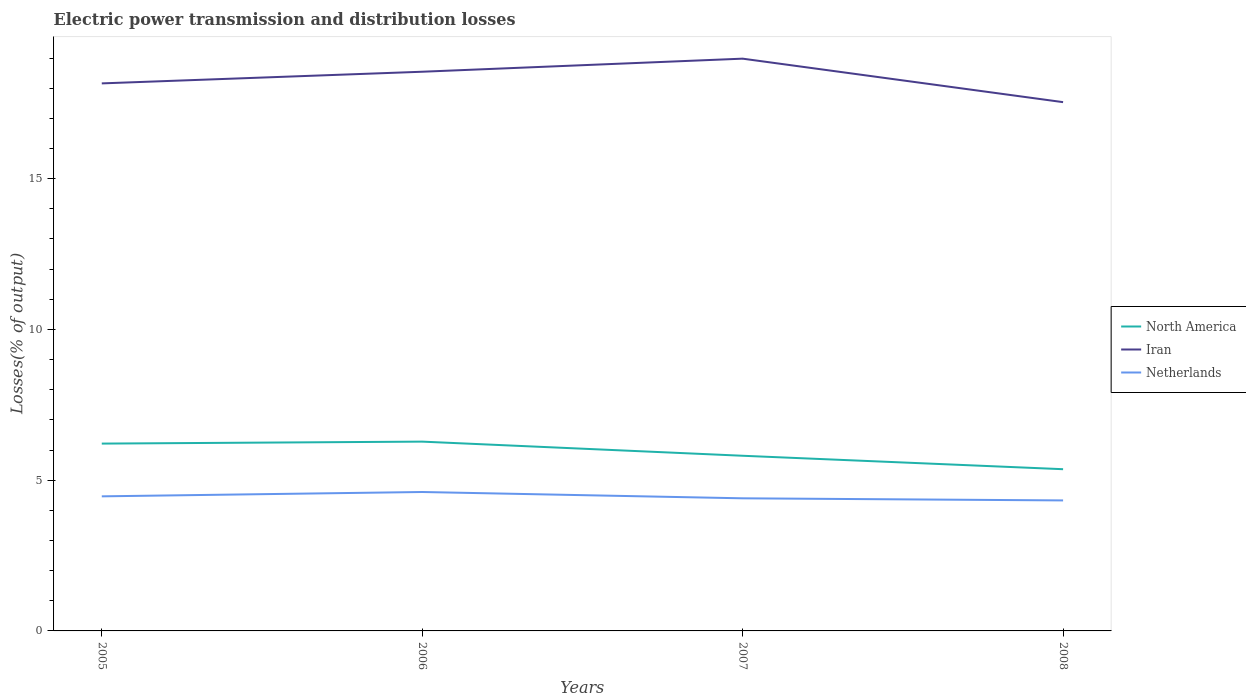Across all years, what is the maximum electric power transmission and distribution losses in North America?
Your answer should be compact. 5.36. In which year was the electric power transmission and distribution losses in North America maximum?
Your answer should be very brief. 2008. What is the total electric power transmission and distribution losses in North America in the graph?
Your response must be concise. 0.91. What is the difference between the highest and the second highest electric power transmission and distribution losses in Netherlands?
Offer a very short reply. 0.28. What is the difference between the highest and the lowest electric power transmission and distribution losses in Iran?
Offer a very short reply. 2. Is the electric power transmission and distribution losses in Iran strictly greater than the electric power transmission and distribution losses in Netherlands over the years?
Make the answer very short. No. What is the difference between two consecutive major ticks on the Y-axis?
Offer a terse response. 5. Are the values on the major ticks of Y-axis written in scientific E-notation?
Your answer should be compact. No. Does the graph contain any zero values?
Ensure brevity in your answer.  No. Does the graph contain grids?
Give a very brief answer. No. Where does the legend appear in the graph?
Offer a very short reply. Center right. How many legend labels are there?
Provide a short and direct response. 3. What is the title of the graph?
Your response must be concise. Electric power transmission and distribution losses. Does "Macedonia" appear as one of the legend labels in the graph?
Ensure brevity in your answer.  No. What is the label or title of the Y-axis?
Your response must be concise. Losses(% of output). What is the Losses(% of output) of North America in 2005?
Your response must be concise. 6.21. What is the Losses(% of output) in Iran in 2005?
Offer a very short reply. 18.16. What is the Losses(% of output) of Netherlands in 2005?
Make the answer very short. 4.46. What is the Losses(% of output) in North America in 2006?
Make the answer very short. 6.28. What is the Losses(% of output) in Iran in 2006?
Your answer should be compact. 18.55. What is the Losses(% of output) in Netherlands in 2006?
Provide a succinct answer. 4.61. What is the Losses(% of output) in North America in 2007?
Your answer should be compact. 5.81. What is the Losses(% of output) of Iran in 2007?
Give a very brief answer. 18.98. What is the Losses(% of output) in Netherlands in 2007?
Your answer should be very brief. 4.4. What is the Losses(% of output) of North America in 2008?
Keep it short and to the point. 5.36. What is the Losses(% of output) in Iran in 2008?
Give a very brief answer. 17.54. What is the Losses(% of output) of Netherlands in 2008?
Offer a terse response. 4.33. Across all years, what is the maximum Losses(% of output) in North America?
Provide a short and direct response. 6.28. Across all years, what is the maximum Losses(% of output) in Iran?
Provide a succinct answer. 18.98. Across all years, what is the maximum Losses(% of output) in Netherlands?
Give a very brief answer. 4.61. Across all years, what is the minimum Losses(% of output) in North America?
Your answer should be compact. 5.36. Across all years, what is the minimum Losses(% of output) of Iran?
Your answer should be compact. 17.54. Across all years, what is the minimum Losses(% of output) of Netherlands?
Offer a very short reply. 4.33. What is the total Losses(% of output) in North America in the graph?
Your response must be concise. 23.66. What is the total Losses(% of output) of Iran in the graph?
Give a very brief answer. 73.22. What is the total Losses(% of output) in Netherlands in the graph?
Ensure brevity in your answer.  17.8. What is the difference between the Losses(% of output) in North America in 2005 and that in 2006?
Keep it short and to the point. -0.07. What is the difference between the Losses(% of output) of Iran in 2005 and that in 2006?
Provide a succinct answer. -0.39. What is the difference between the Losses(% of output) in Netherlands in 2005 and that in 2006?
Provide a short and direct response. -0.14. What is the difference between the Losses(% of output) of North America in 2005 and that in 2007?
Ensure brevity in your answer.  0.4. What is the difference between the Losses(% of output) of Iran in 2005 and that in 2007?
Offer a terse response. -0.82. What is the difference between the Losses(% of output) in Netherlands in 2005 and that in 2007?
Give a very brief answer. 0.07. What is the difference between the Losses(% of output) of North America in 2005 and that in 2008?
Ensure brevity in your answer.  0.85. What is the difference between the Losses(% of output) of Iran in 2005 and that in 2008?
Ensure brevity in your answer.  0.62. What is the difference between the Losses(% of output) in Netherlands in 2005 and that in 2008?
Your answer should be very brief. 0.14. What is the difference between the Losses(% of output) in North America in 2006 and that in 2007?
Your answer should be compact. 0.47. What is the difference between the Losses(% of output) of Iran in 2006 and that in 2007?
Make the answer very short. -0.43. What is the difference between the Losses(% of output) in Netherlands in 2006 and that in 2007?
Keep it short and to the point. 0.21. What is the difference between the Losses(% of output) of North America in 2006 and that in 2008?
Your answer should be compact. 0.91. What is the difference between the Losses(% of output) of Iran in 2006 and that in 2008?
Make the answer very short. 1.01. What is the difference between the Losses(% of output) in Netherlands in 2006 and that in 2008?
Provide a short and direct response. 0.28. What is the difference between the Losses(% of output) in North America in 2007 and that in 2008?
Keep it short and to the point. 0.45. What is the difference between the Losses(% of output) in Iran in 2007 and that in 2008?
Offer a very short reply. 1.44. What is the difference between the Losses(% of output) of Netherlands in 2007 and that in 2008?
Ensure brevity in your answer.  0.07. What is the difference between the Losses(% of output) in North America in 2005 and the Losses(% of output) in Iran in 2006?
Give a very brief answer. -12.33. What is the difference between the Losses(% of output) of North America in 2005 and the Losses(% of output) of Netherlands in 2006?
Your response must be concise. 1.61. What is the difference between the Losses(% of output) in Iran in 2005 and the Losses(% of output) in Netherlands in 2006?
Offer a very short reply. 13.55. What is the difference between the Losses(% of output) of North America in 2005 and the Losses(% of output) of Iran in 2007?
Provide a short and direct response. -12.77. What is the difference between the Losses(% of output) in North America in 2005 and the Losses(% of output) in Netherlands in 2007?
Provide a short and direct response. 1.81. What is the difference between the Losses(% of output) of Iran in 2005 and the Losses(% of output) of Netherlands in 2007?
Ensure brevity in your answer.  13.76. What is the difference between the Losses(% of output) in North America in 2005 and the Losses(% of output) in Iran in 2008?
Give a very brief answer. -11.32. What is the difference between the Losses(% of output) of North America in 2005 and the Losses(% of output) of Netherlands in 2008?
Your response must be concise. 1.88. What is the difference between the Losses(% of output) in Iran in 2005 and the Losses(% of output) in Netherlands in 2008?
Give a very brief answer. 13.83. What is the difference between the Losses(% of output) in North America in 2006 and the Losses(% of output) in Iran in 2007?
Your answer should be very brief. -12.7. What is the difference between the Losses(% of output) in North America in 2006 and the Losses(% of output) in Netherlands in 2007?
Your answer should be compact. 1.88. What is the difference between the Losses(% of output) of Iran in 2006 and the Losses(% of output) of Netherlands in 2007?
Make the answer very short. 14.15. What is the difference between the Losses(% of output) of North America in 2006 and the Losses(% of output) of Iran in 2008?
Your response must be concise. -11.26. What is the difference between the Losses(% of output) of North America in 2006 and the Losses(% of output) of Netherlands in 2008?
Ensure brevity in your answer.  1.95. What is the difference between the Losses(% of output) of Iran in 2006 and the Losses(% of output) of Netherlands in 2008?
Give a very brief answer. 14.22. What is the difference between the Losses(% of output) in North America in 2007 and the Losses(% of output) in Iran in 2008?
Offer a very short reply. -11.73. What is the difference between the Losses(% of output) of North America in 2007 and the Losses(% of output) of Netherlands in 2008?
Provide a succinct answer. 1.48. What is the difference between the Losses(% of output) in Iran in 2007 and the Losses(% of output) in Netherlands in 2008?
Offer a terse response. 14.65. What is the average Losses(% of output) of North America per year?
Provide a short and direct response. 5.92. What is the average Losses(% of output) of Iran per year?
Give a very brief answer. 18.3. What is the average Losses(% of output) in Netherlands per year?
Keep it short and to the point. 4.45. In the year 2005, what is the difference between the Losses(% of output) of North America and Losses(% of output) of Iran?
Ensure brevity in your answer.  -11.95. In the year 2005, what is the difference between the Losses(% of output) of North America and Losses(% of output) of Netherlands?
Ensure brevity in your answer.  1.75. In the year 2005, what is the difference between the Losses(% of output) in Iran and Losses(% of output) in Netherlands?
Keep it short and to the point. 13.7. In the year 2006, what is the difference between the Losses(% of output) of North America and Losses(% of output) of Iran?
Your answer should be compact. -12.27. In the year 2006, what is the difference between the Losses(% of output) in North America and Losses(% of output) in Netherlands?
Your response must be concise. 1.67. In the year 2006, what is the difference between the Losses(% of output) in Iran and Losses(% of output) in Netherlands?
Make the answer very short. 13.94. In the year 2007, what is the difference between the Losses(% of output) of North America and Losses(% of output) of Iran?
Offer a terse response. -13.17. In the year 2007, what is the difference between the Losses(% of output) in North America and Losses(% of output) in Netherlands?
Provide a succinct answer. 1.41. In the year 2007, what is the difference between the Losses(% of output) of Iran and Losses(% of output) of Netherlands?
Keep it short and to the point. 14.58. In the year 2008, what is the difference between the Losses(% of output) in North America and Losses(% of output) in Iran?
Ensure brevity in your answer.  -12.17. In the year 2008, what is the difference between the Losses(% of output) of North America and Losses(% of output) of Netherlands?
Your response must be concise. 1.04. In the year 2008, what is the difference between the Losses(% of output) of Iran and Losses(% of output) of Netherlands?
Make the answer very short. 13.21. What is the ratio of the Losses(% of output) of North America in 2005 to that in 2006?
Your answer should be very brief. 0.99. What is the ratio of the Losses(% of output) of Iran in 2005 to that in 2006?
Provide a short and direct response. 0.98. What is the ratio of the Losses(% of output) of Netherlands in 2005 to that in 2006?
Your answer should be compact. 0.97. What is the ratio of the Losses(% of output) in North America in 2005 to that in 2007?
Offer a very short reply. 1.07. What is the ratio of the Losses(% of output) in Iran in 2005 to that in 2007?
Ensure brevity in your answer.  0.96. What is the ratio of the Losses(% of output) in Netherlands in 2005 to that in 2007?
Offer a very short reply. 1.01. What is the ratio of the Losses(% of output) in North America in 2005 to that in 2008?
Provide a short and direct response. 1.16. What is the ratio of the Losses(% of output) in Iran in 2005 to that in 2008?
Offer a very short reply. 1.04. What is the ratio of the Losses(% of output) in Netherlands in 2005 to that in 2008?
Ensure brevity in your answer.  1.03. What is the ratio of the Losses(% of output) in North America in 2006 to that in 2007?
Your answer should be compact. 1.08. What is the ratio of the Losses(% of output) in Iran in 2006 to that in 2007?
Give a very brief answer. 0.98. What is the ratio of the Losses(% of output) of Netherlands in 2006 to that in 2007?
Provide a short and direct response. 1.05. What is the ratio of the Losses(% of output) of North America in 2006 to that in 2008?
Give a very brief answer. 1.17. What is the ratio of the Losses(% of output) of Iran in 2006 to that in 2008?
Your answer should be compact. 1.06. What is the ratio of the Losses(% of output) of Netherlands in 2006 to that in 2008?
Provide a succinct answer. 1.06. What is the ratio of the Losses(% of output) of North America in 2007 to that in 2008?
Offer a terse response. 1.08. What is the ratio of the Losses(% of output) of Iran in 2007 to that in 2008?
Offer a very short reply. 1.08. What is the ratio of the Losses(% of output) in Netherlands in 2007 to that in 2008?
Your response must be concise. 1.02. What is the difference between the highest and the second highest Losses(% of output) of North America?
Provide a succinct answer. 0.07. What is the difference between the highest and the second highest Losses(% of output) in Iran?
Your answer should be very brief. 0.43. What is the difference between the highest and the second highest Losses(% of output) in Netherlands?
Your response must be concise. 0.14. What is the difference between the highest and the lowest Losses(% of output) in North America?
Ensure brevity in your answer.  0.91. What is the difference between the highest and the lowest Losses(% of output) in Iran?
Your answer should be very brief. 1.44. What is the difference between the highest and the lowest Losses(% of output) in Netherlands?
Keep it short and to the point. 0.28. 